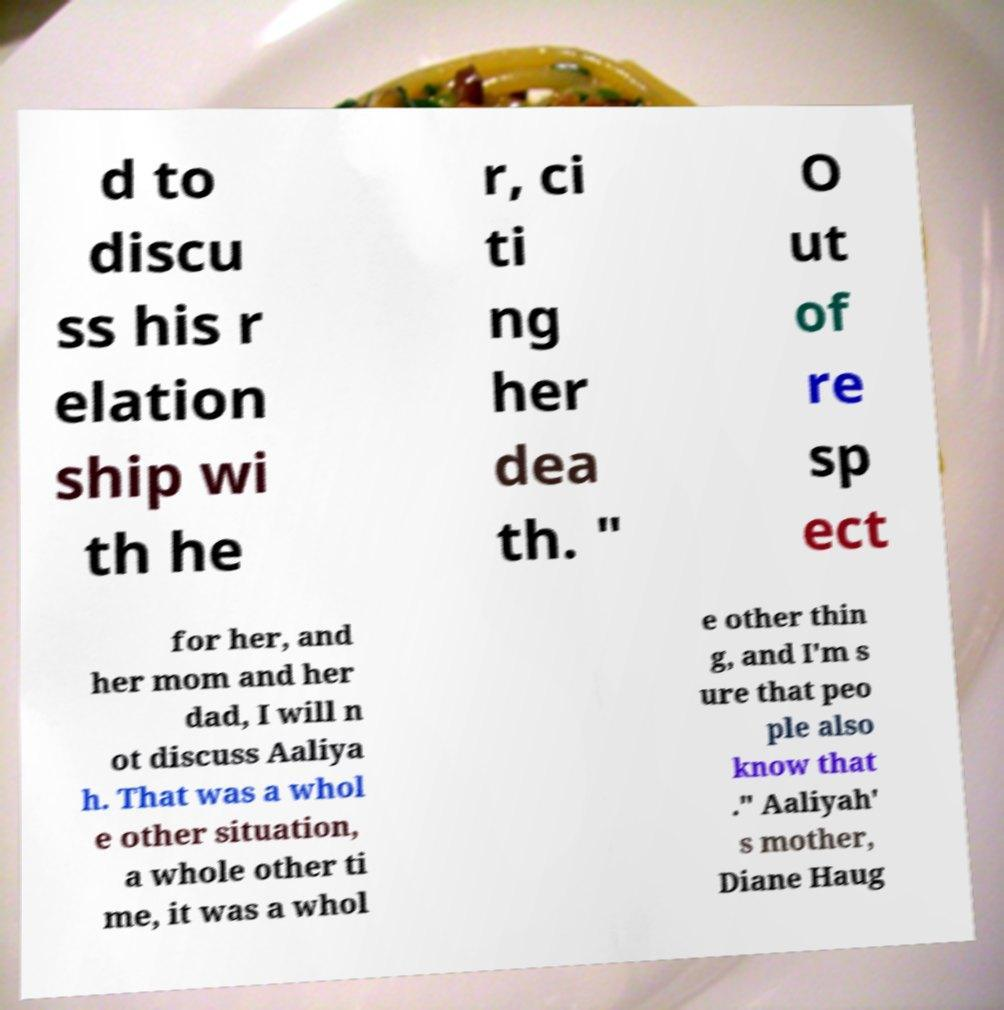Can you accurately transcribe the text from the provided image for me? d to discu ss his r elation ship wi th he r, ci ti ng her dea th. " O ut of re sp ect for her, and her mom and her dad, I will n ot discuss Aaliya h. That was a whol e other situation, a whole other ti me, it was a whol e other thin g, and I'm s ure that peo ple also know that ." Aaliyah' s mother, Diane Haug 